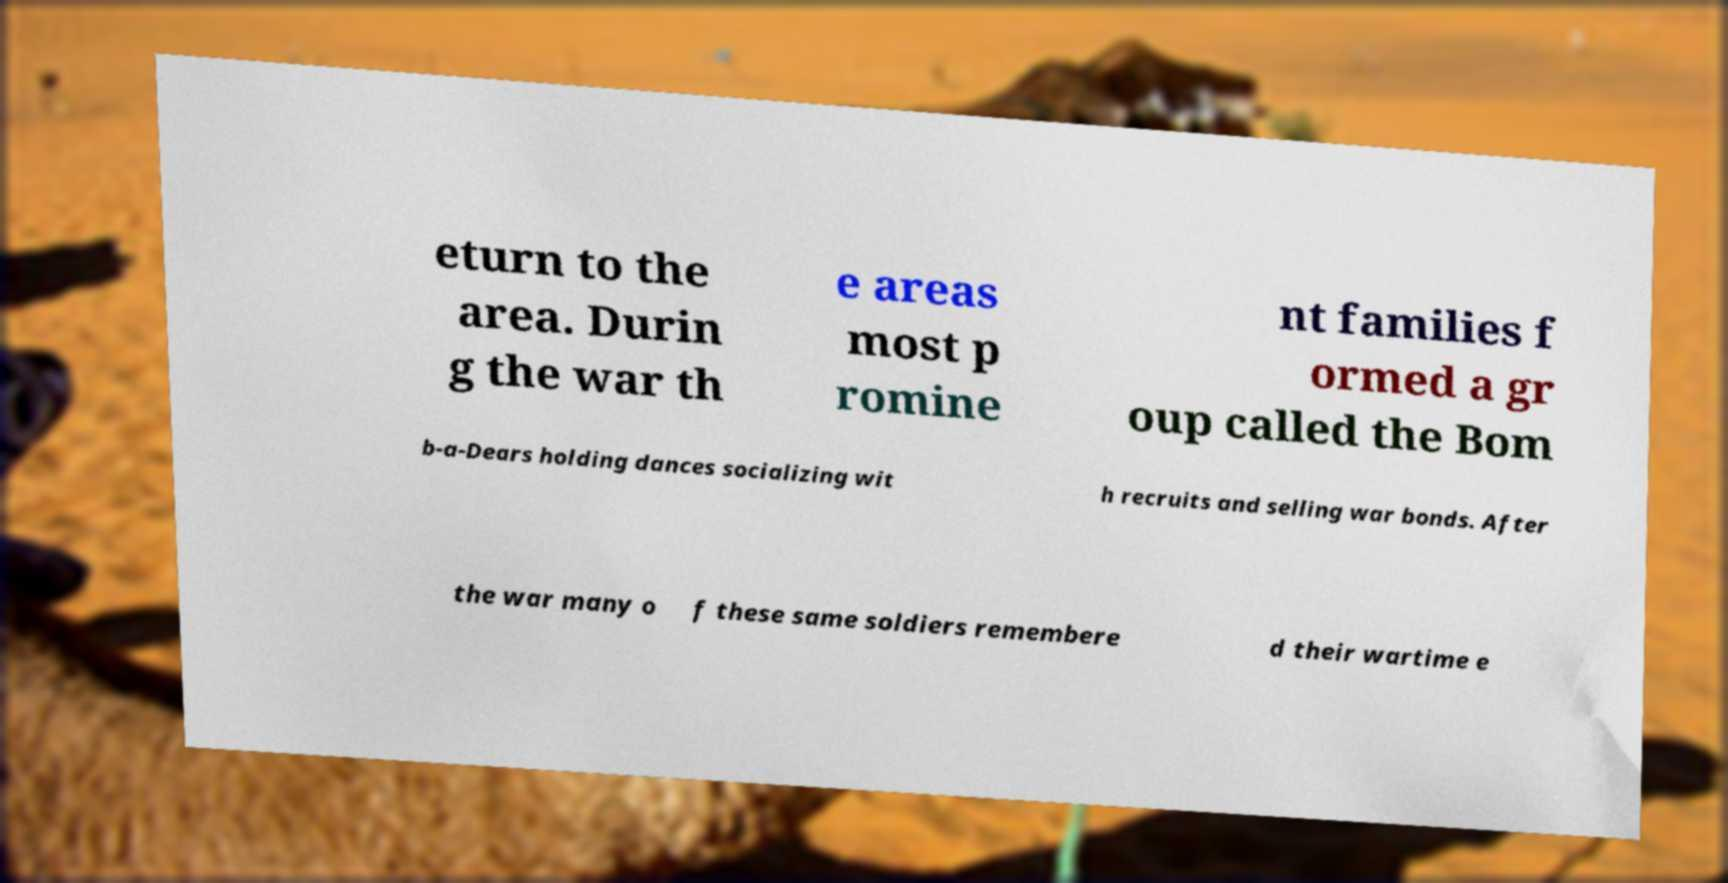Can you read and provide the text displayed in the image?This photo seems to have some interesting text. Can you extract and type it out for me? eturn to the area. Durin g the war th e areas most p romine nt families f ormed a gr oup called the Bom b-a-Dears holding dances socializing wit h recruits and selling war bonds. After the war many o f these same soldiers remembere d their wartime e 